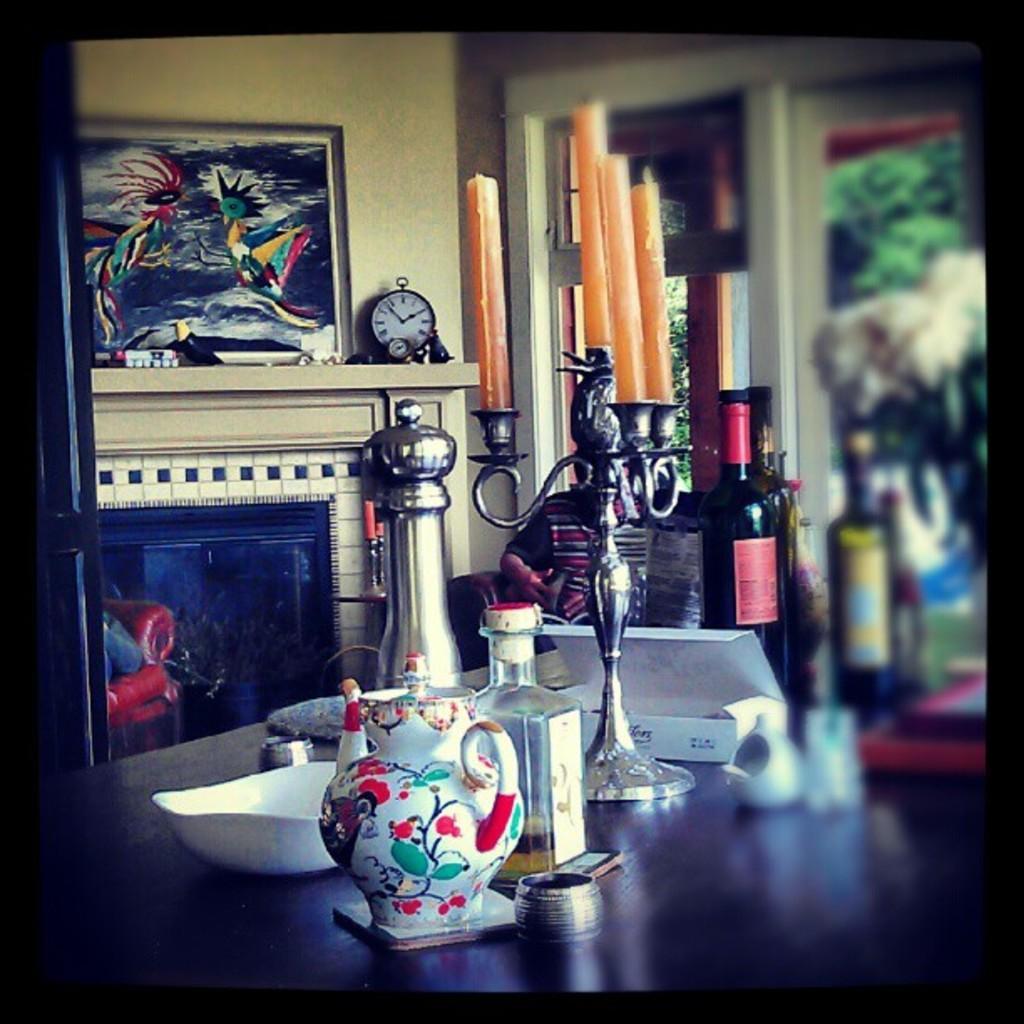How would you summarize this image in a sentence or two? In this image there is a table on which there are jars,bowl,glass bottles,boxes and some metal stands. In the background there is a painting which is kept on the wall. Beside the painting there is a clock. There is a candle stand on the table. At the bottom there is a sofa. On the right side there is a flower vase. In the background there are windows. 